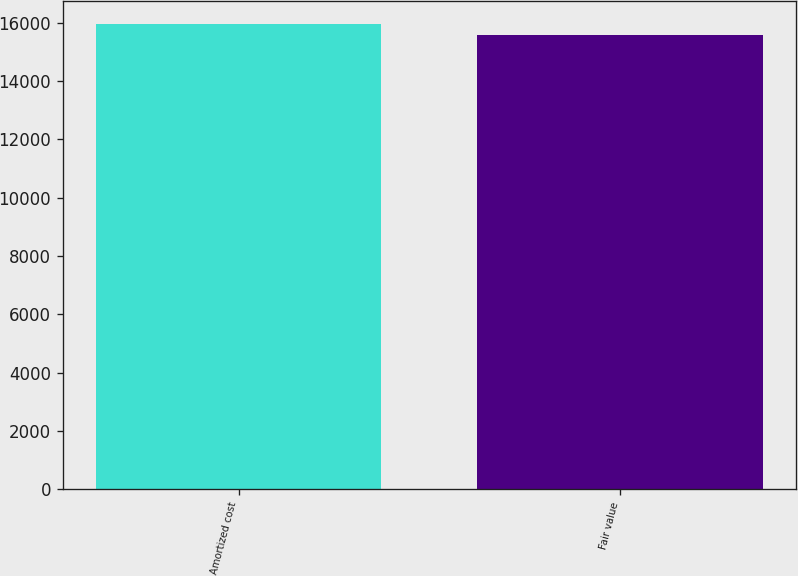Convert chart to OTSL. <chart><loc_0><loc_0><loc_500><loc_500><bar_chart><fcel>Amortized cost<fcel>Fair value<nl><fcel>15948<fcel>15563<nl></chart> 